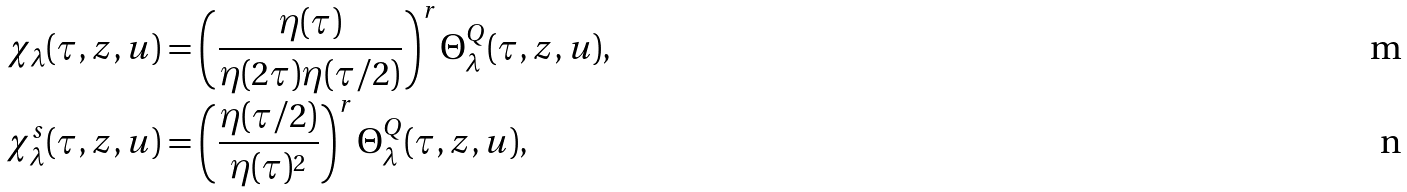<formula> <loc_0><loc_0><loc_500><loc_500>\chi _ { \lambda } ( \tau , z , u ) & = \left ( \frac { \eta ( \tau ) } { \eta ( 2 \tau ) \eta ( \tau / 2 ) } \right ) ^ { r } \Theta _ { \lambda } ^ { Q } ( \tau , z , u ) , \\ \chi ^ { s } _ { \lambda } ( \tau , z , u ) & = \left ( \frac { \eta ( \tau / 2 ) } { \eta ( \tau ) ^ { 2 } } \right ) ^ { r } \Theta _ { \lambda } ^ { Q } ( \tau , z , u ) ,</formula> 